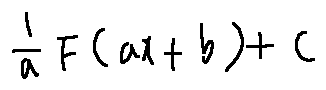Convert formula to latex. <formula><loc_0><loc_0><loc_500><loc_500>\frac { 1 } { a } F ( a x + b ) + C</formula> 